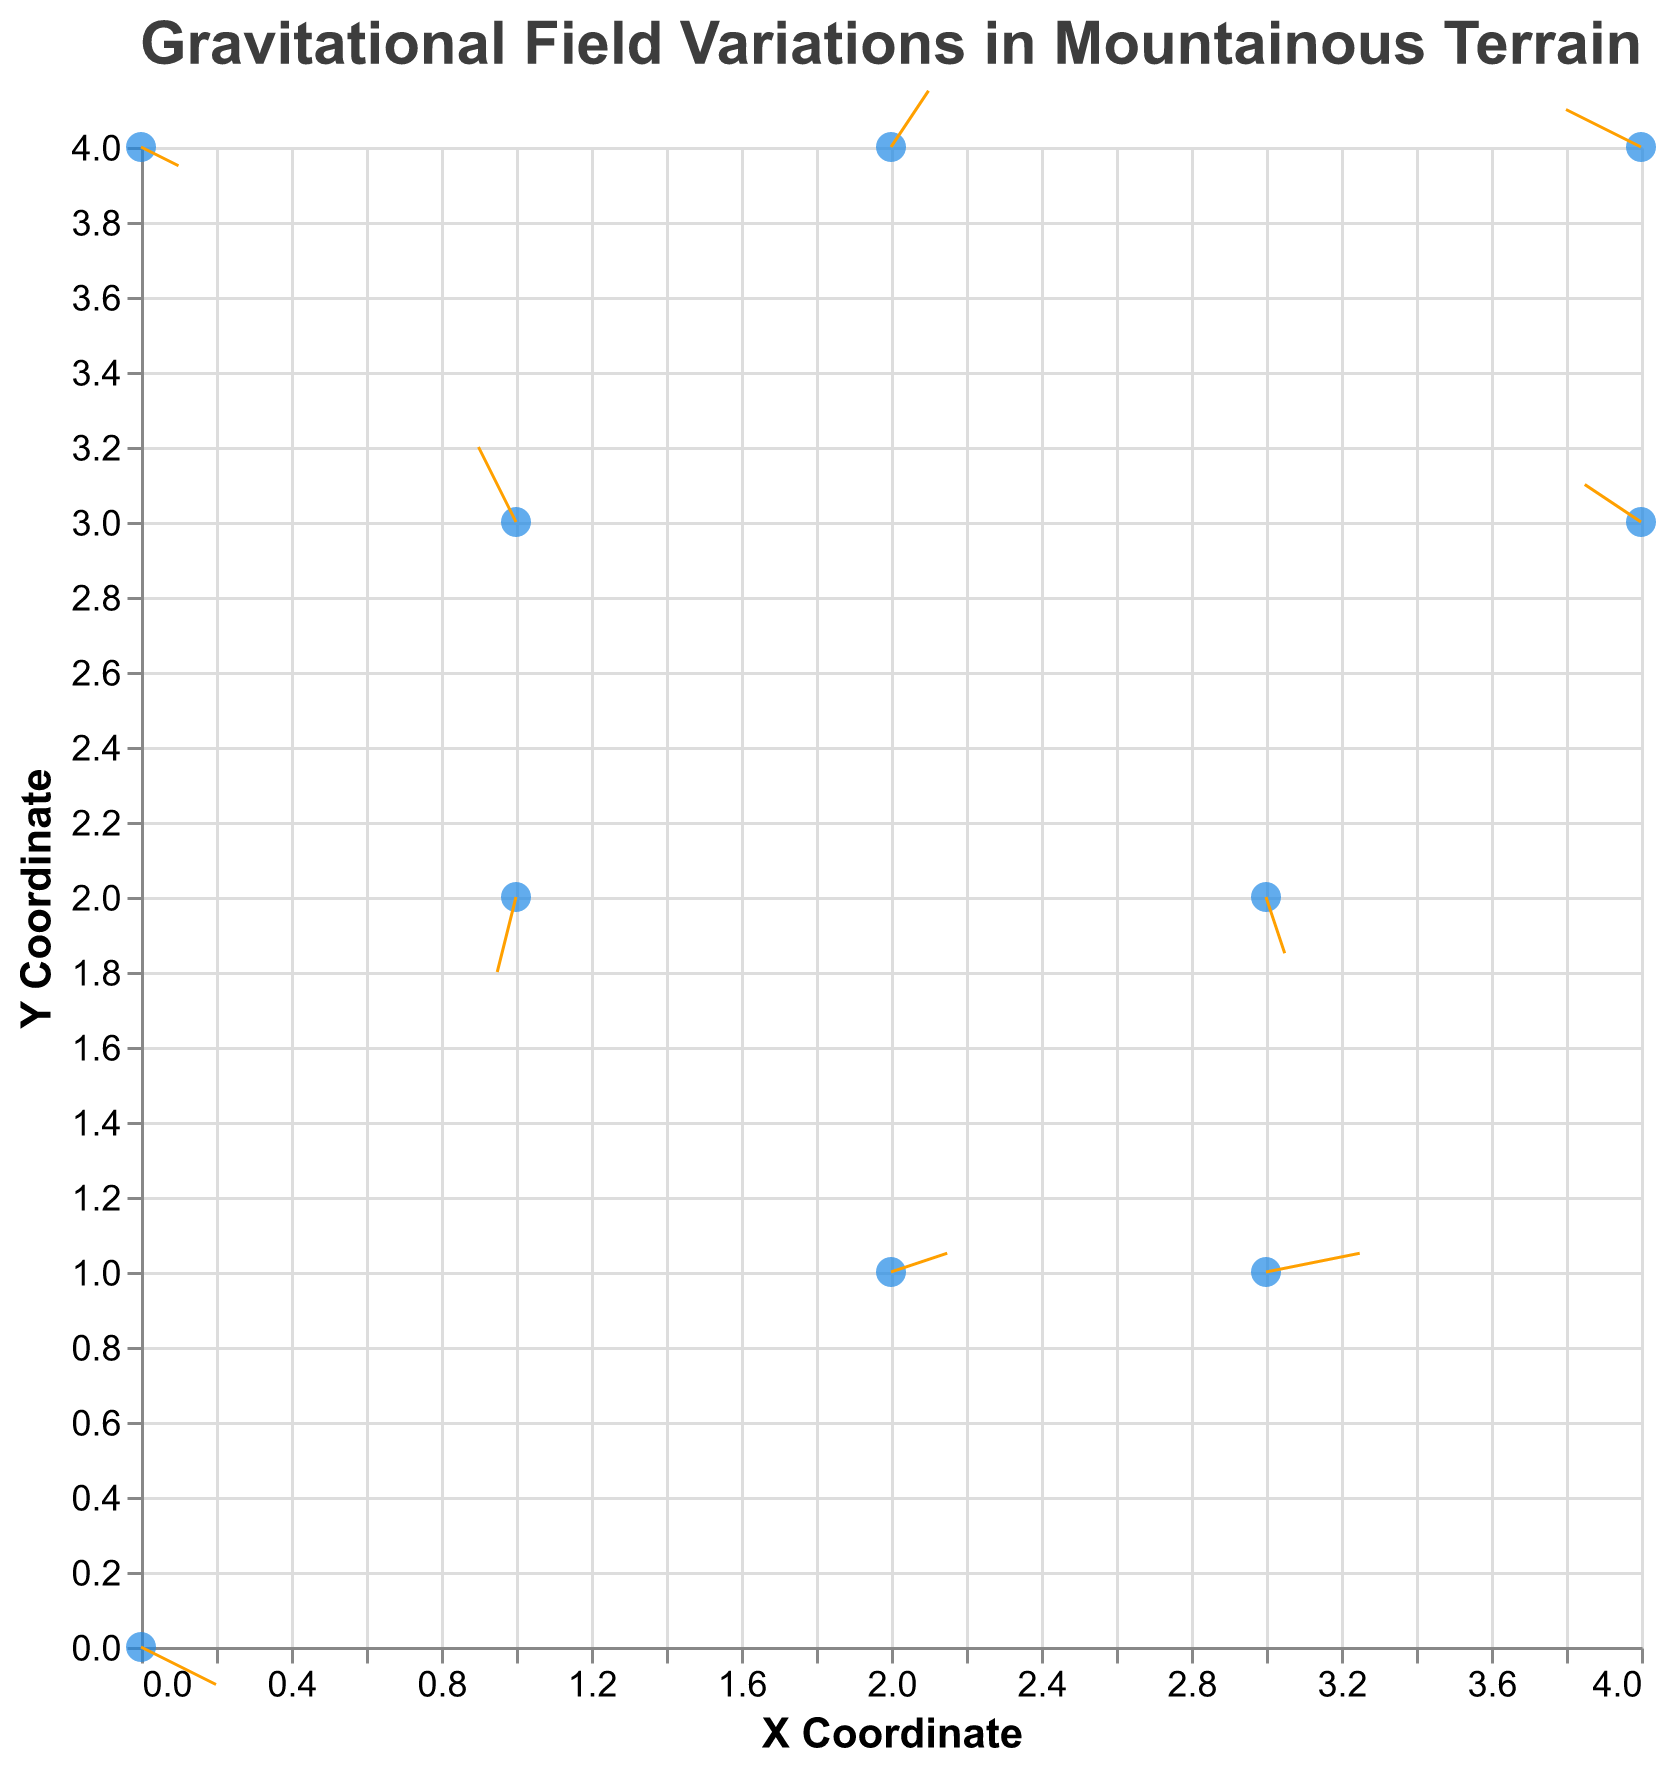What's the title of the figure? The title is typically located at the top of the figure and it reads "Gravitational Field Variations in Mountainous Terrain".
Answer: Gravitational Field Variations in Mountainous Terrain How many data points are there in the figure? The figure contains 10 points, each representing a different location.
Answer: 10 Which location has the largest positive x-component of the gravitational field variation? Look for the arrow with the largest positive dx. The largest positive dx is 0.25 at the "Half Dome SubDome" location.
Answer: Half Dome SubDome Which location has the largest negative y-component of the gravitational field variation? Look for the arrow with the largest negative dy. The largest negative dy is -0.2 at the "El Capitan Base" location.
Answer: El Capitan Base At Mont Blanc Goûter Hut, what are dx and dy of the gravitational field variation? The values of dx and dy can be read directly at the "Mont Blanc Goûter Hut" data point, which are -0.2 and 0.1, respectively.
Answer: dx: -0.2, dy: 0.1 What's the combined variation (vector sum) of the gravitational field at the Half Dome SubDome? The variation vector can be calculated by finding the magnitude of the vector (dx, dy) = (0.25, 0.05), which is sqrt(0.25^2 + 0.05^2) = sqrt(0.0625 + 0.0025) = sqrt(0.065) ≈ 0.255.
Answer: ≈ 0.255 Which location's arrow points the closest to straight downward (negative y-axis)? The location with the arrow mostly pointing downward will have a significantly negative dy and very small dx. "El Capitan Base" has dx = -0.05, dy = -0.2, largely pointing downward.
Answer: El Capitan Base Compare the direction of the gravitational field variation at Mount Everest Base Camp and K2 Advanced Base Camp. Which one has a stronger negative y-component? Check the dy values for both locations: Mount Everest Base Camp has dy = -0.1 and K2 Advanced Base Camp has dy = 0.05. Hence, Mount Everest Base Camp has the stronger negative y-component.
Answer: Mount Everest Base Camp Which location shows a gravitational field variation pointing to the top-right (positive x and positive y)? Directions pointing top-right will have both dx > 0 and dy > 0. The locations are "K2 Advanced Base Camp" (dx = 0.15, dy = 0.05) and "Matterhorn Hörnli Hut" (dx = 0.1, dy = 0.15).
Answer: K2 Advanced Base Camp, Matterhorn Hörnli Hut What is the dominant direction of the gravitational field variation at Denali 14000 ft Camp? Identify if dx or dy values are larger in magnitude to determine dominance: dx = 0.05, dy = -0.15. Since dy has a greater deviation, the dominant direction is downward.
Answer: Downward 